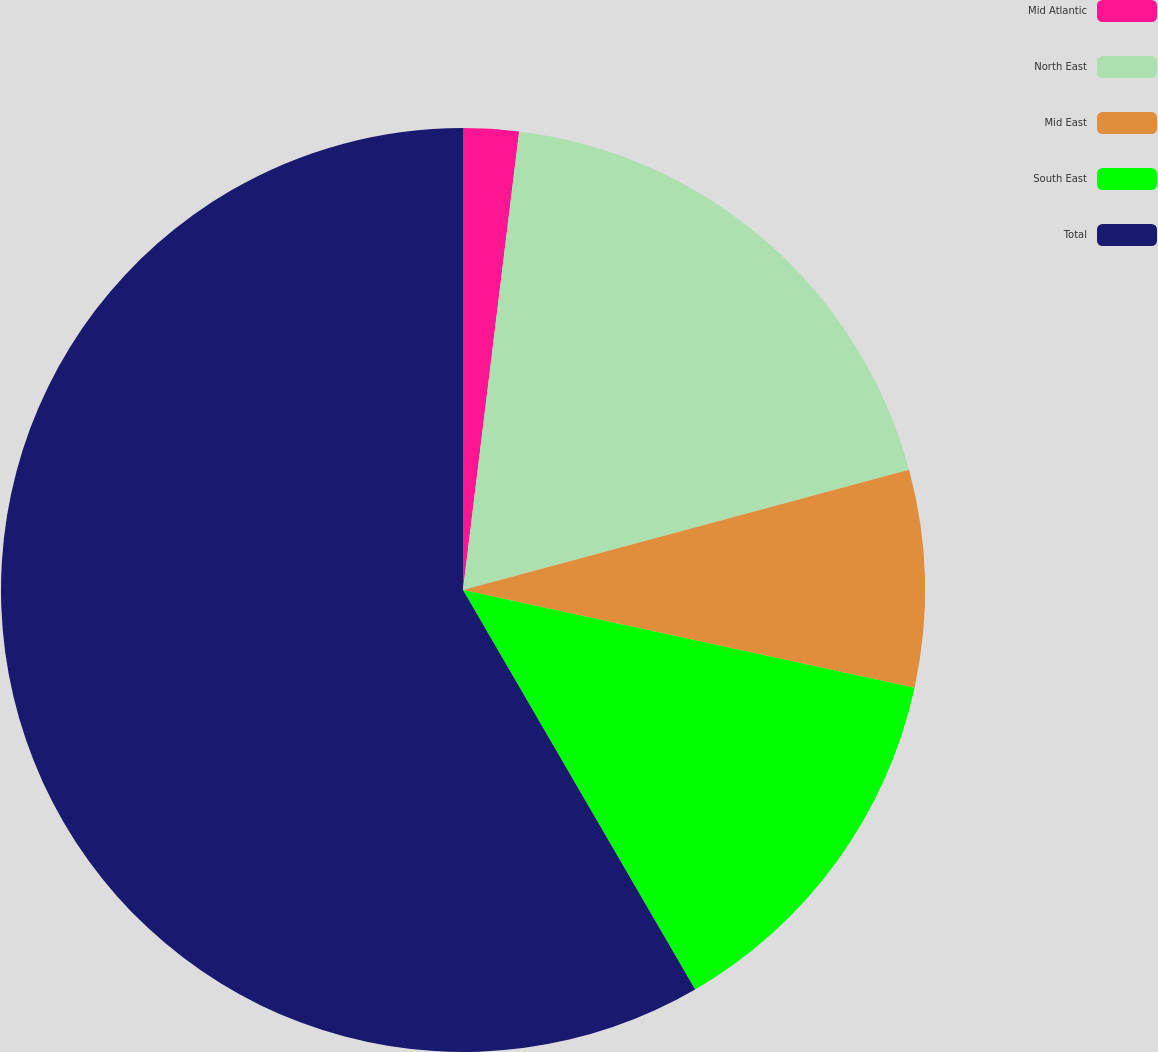<chart> <loc_0><loc_0><loc_500><loc_500><pie_chart><fcel>Mid Atlantic<fcel>North East<fcel>Mid East<fcel>South East<fcel>Total<nl><fcel>1.94%<fcel>18.87%<fcel>7.58%<fcel>13.23%<fcel>58.38%<nl></chart> 